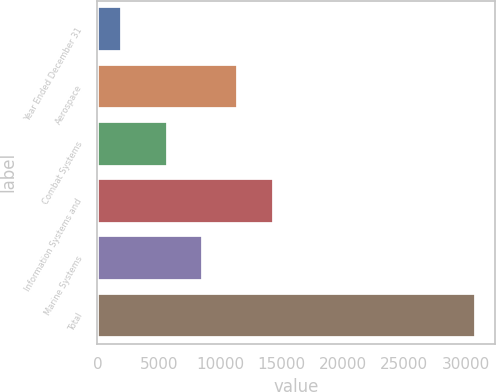<chart> <loc_0><loc_0><loc_500><loc_500><bar_chart><fcel>Year Ended December 31<fcel>Aerospace<fcel>Combat Systems<fcel>Information Systems and<fcel>Marine Systems<fcel>Total<nl><fcel>2014<fcel>11499.6<fcel>5732<fcel>14383.4<fcel>8615.8<fcel>30852<nl></chart> 